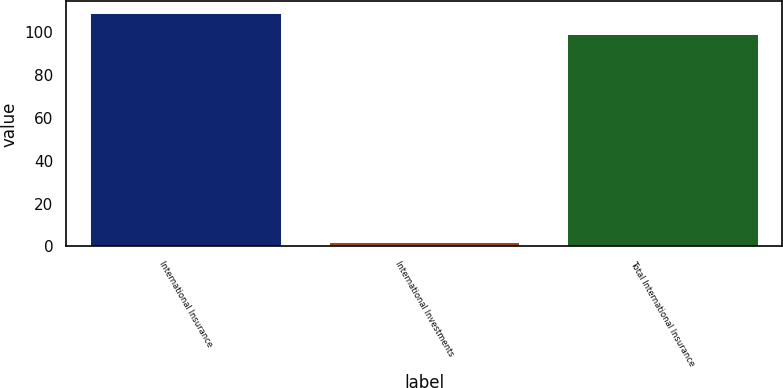Convert chart to OTSL. <chart><loc_0><loc_0><loc_500><loc_500><bar_chart><fcel>International Insurance<fcel>International Investments<fcel>Total International Insurance<nl><fcel>108.9<fcel>2<fcel>99<nl></chart> 